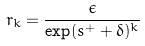Convert formula to latex. <formula><loc_0><loc_0><loc_500><loc_500>r _ { k } = \frac { \epsilon } { \exp ( s ^ { + } + \delta ) ^ { k } }</formula> 